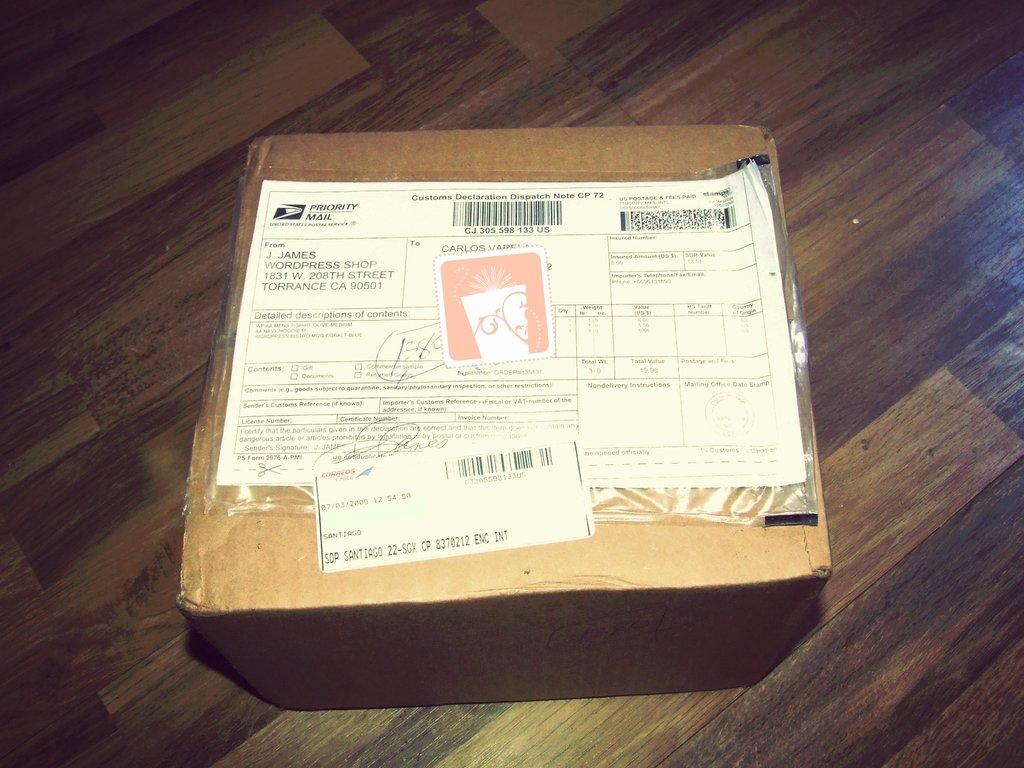Who is the recipient of the parcel?
Keep it short and to the point. J james. Is priority  mail from the usps?
Offer a very short reply. Yes. 